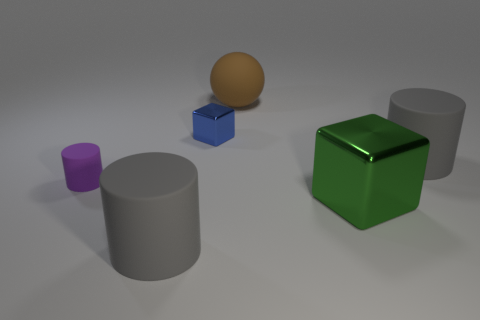Subtract all large rubber cylinders. How many cylinders are left? 1 Subtract all blue cubes. How many cubes are left? 1 Add 3 large spheres. How many objects exist? 9 Subtract all blocks. How many objects are left? 4 Subtract 0 cyan spheres. How many objects are left? 6 Subtract 2 blocks. How many blocks are left? 0 Subtract all yellow cylinders. Subtract all yellow balls. How many cylinders are left? 3 Subtract all gray balls. How many yellow cylinders are left? 0 Subtract all small rubber things. Subtract all green things. How many objects are left? 4 Add 5 tiny purple rubber objects. How many tiny purple rubber objects are left? 6 